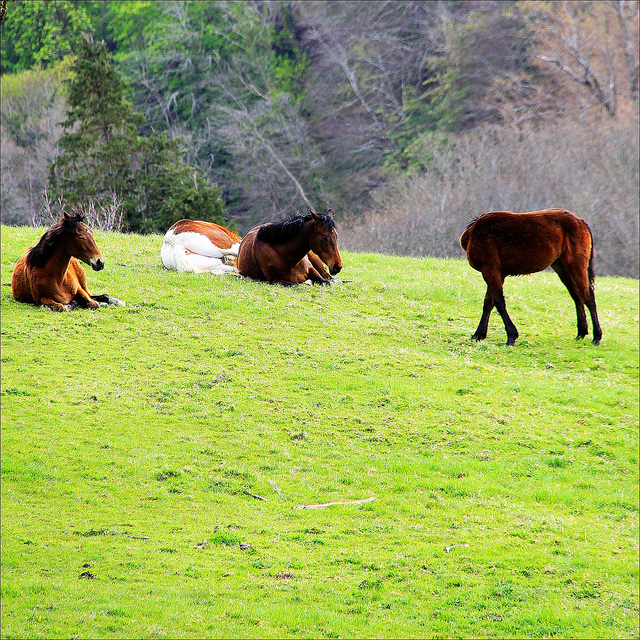<image>Are the trees blooming? It is ambiguous if the trees are blooming. But it is mostly seen as no. Are the horses tired? I don't know if the horses are tired. Are the trees blooming? I am not sure if the trees are blooming. It seems like they are not blooming. Are the horses tired? I don't know if the horses are tired. They can be tired or not. 